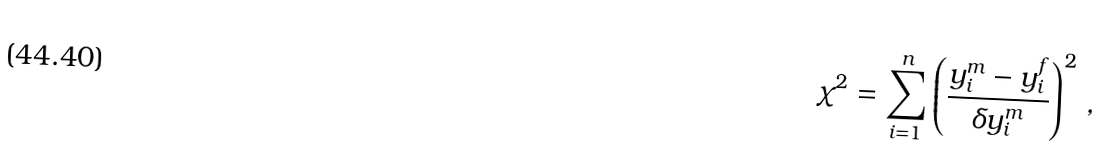<formula> <loc_0><loc_0><loc_500><loc_500>\chi ^ { 2 } = \sum _ { i = 1 } ^ { n } \left ( \frac { y _ { i } ^ { m } - y _ { i } ^ { f } } { \delta y _ { i } ^ { m } } \right ) ^ { 2 } \, ,</formula> 